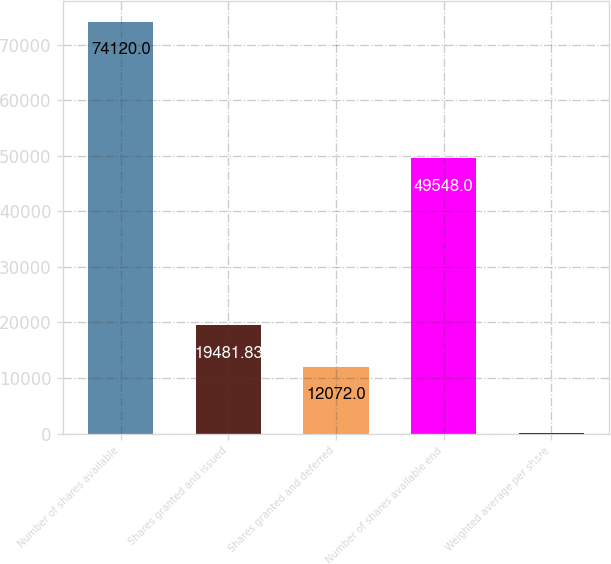<chart> <loc_0><loc_0><loc_500><loc_500><bar_chart><fcel>Number of shares available<fcel>Shares granted and issued<fcel>Shares granted and deferred<fcel>Number of shares available end<fcel>Weighted average per share<nl><fcel>74120<fcel>19481.8<fcel>12072<fcel>49548<fcel>21.72<nl></chart> 